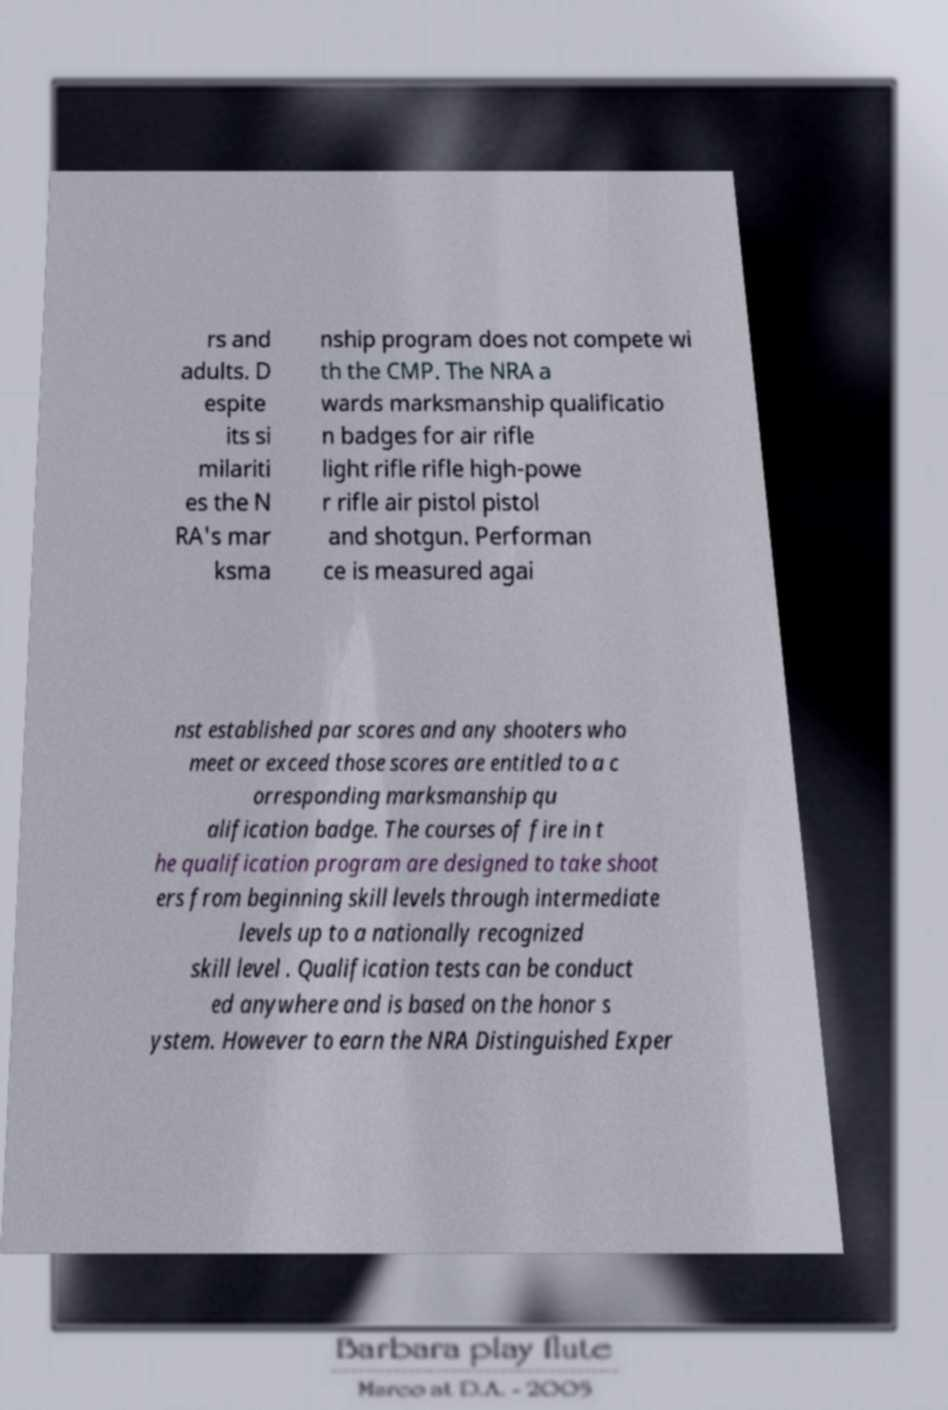Could you extract and type out the text from this image? rs and adults. D espite its si milariti es the N RA's mar ksma nship program does not compete wi th the CMP. The NRA a wards marksmanship qualificatio n badges for air rifle light rifle rifle high-powe r rifle air pistol pistol and shotgun. Performan ce is measured agai nst established par scores and any shooters who meet or exceed those scores are entitled to a c orresponding marksmanship qu alification badge. The courses of fire in t he qualification program are designed to take shoot ers from beginning skill levels through intermediate levels up to a nationally recognized skill level . Qualification tests can be conduct ed anywhere and is based on the honor s ystem. However to earn the NRA Distinguished Exper 